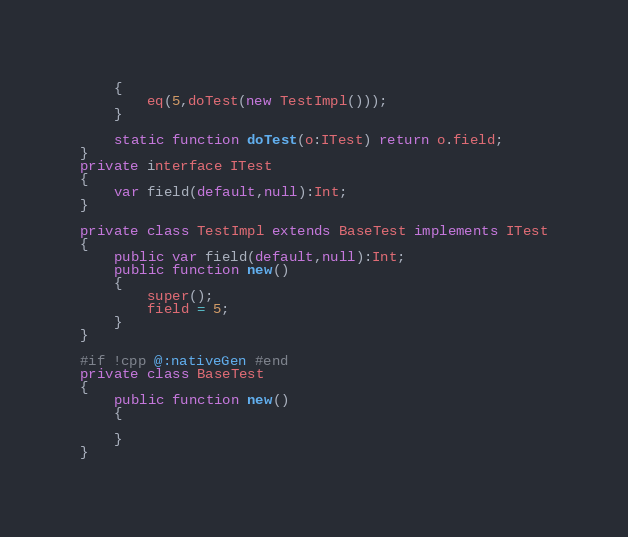<code> <loc_0><loc_0><loc_500><loc_500><_Haxe_>	{
		eq(5,doTest(new TestImpl()));
	}

	static function doTest(o:ITest) return o.field;
}
private interface ITest
{
	var field(default,null):Int;
}

private class TestImpl extends BaseTest implements ITest
{
	public var field(default,null):Int;
	public function new()
	{
		super();
		field = 5;
	}
}

#if !cpp @:nativeGen #end
private class BaseTest
{
	public function new()
	{

	}
}
</code> 